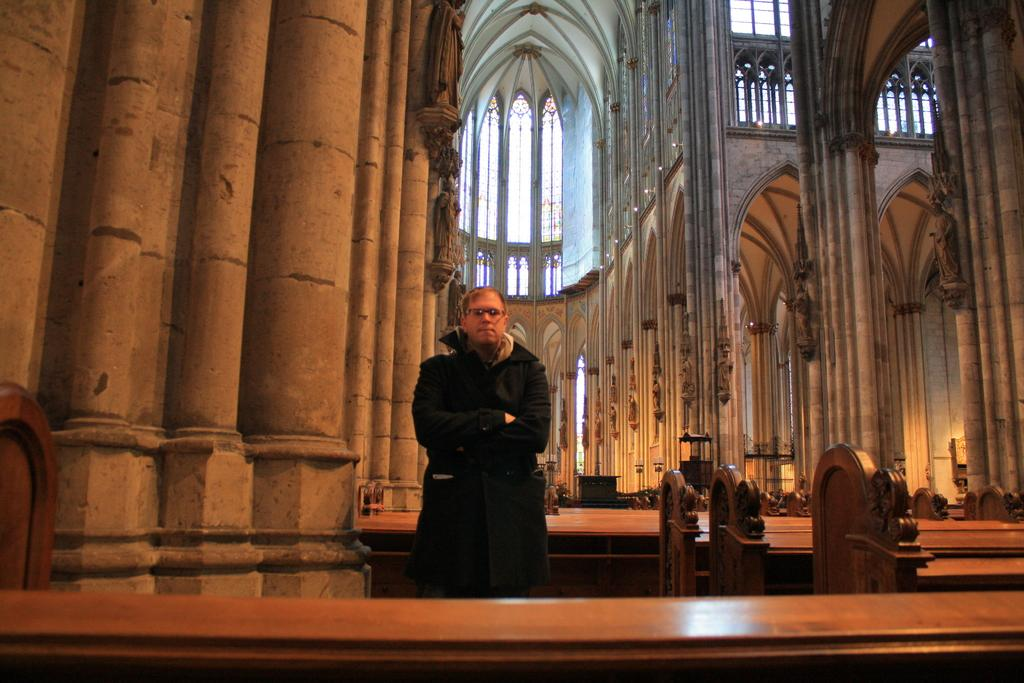What is the main subject of the image? There is a person standing in the image. Can you describe the person's surroundings? The person is standing between benches, and there are pillars around them. What type of mist can be seen surrounding the person in the image? There is no mist present in the image; it is a clear scene with the person standing between benches and surrounded by pillars. Can you tell me how many socks the person is wearing in the image? There is no information about the person's socks in the image, so it cannot be determined. 